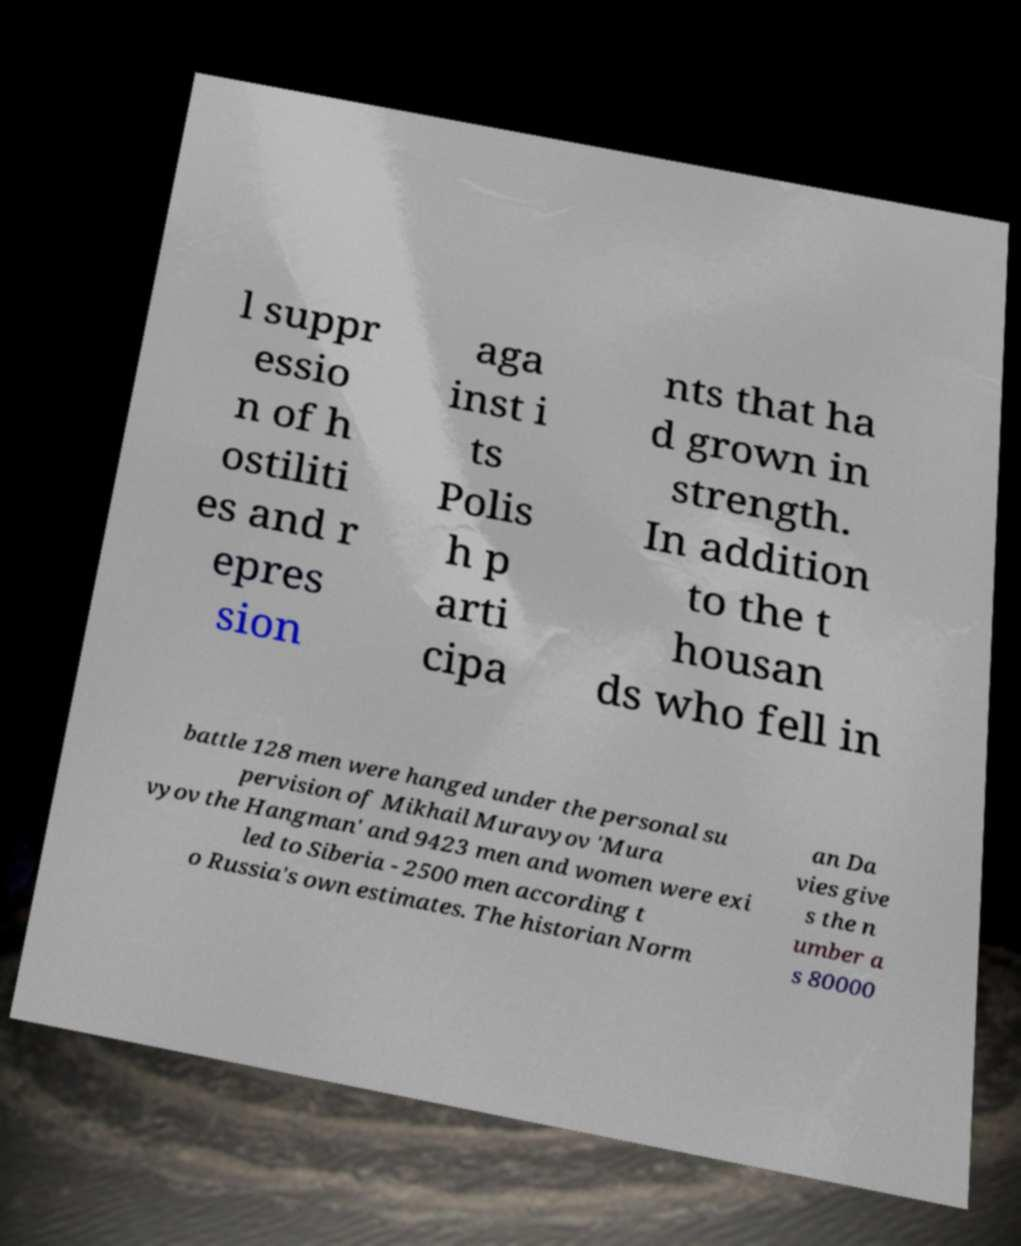Could you assist in decoding the text presented in this image and type it out clearly? l suppr essio n of h ostiliti es and r epres sion aga inst i ts Polis h p arti cipa nts that ha d grown in strength. In addition to the t housan ds who fell in battle 128 men were hanged under the personal su pervision of Mikhail Muravyov 'Mura vyov the Hangman' and 9423 men and women were exi led to Siberia - 2500 men according t o Russia's own estimates. The historian Norm an Da vies give s the n umber a s 80000 